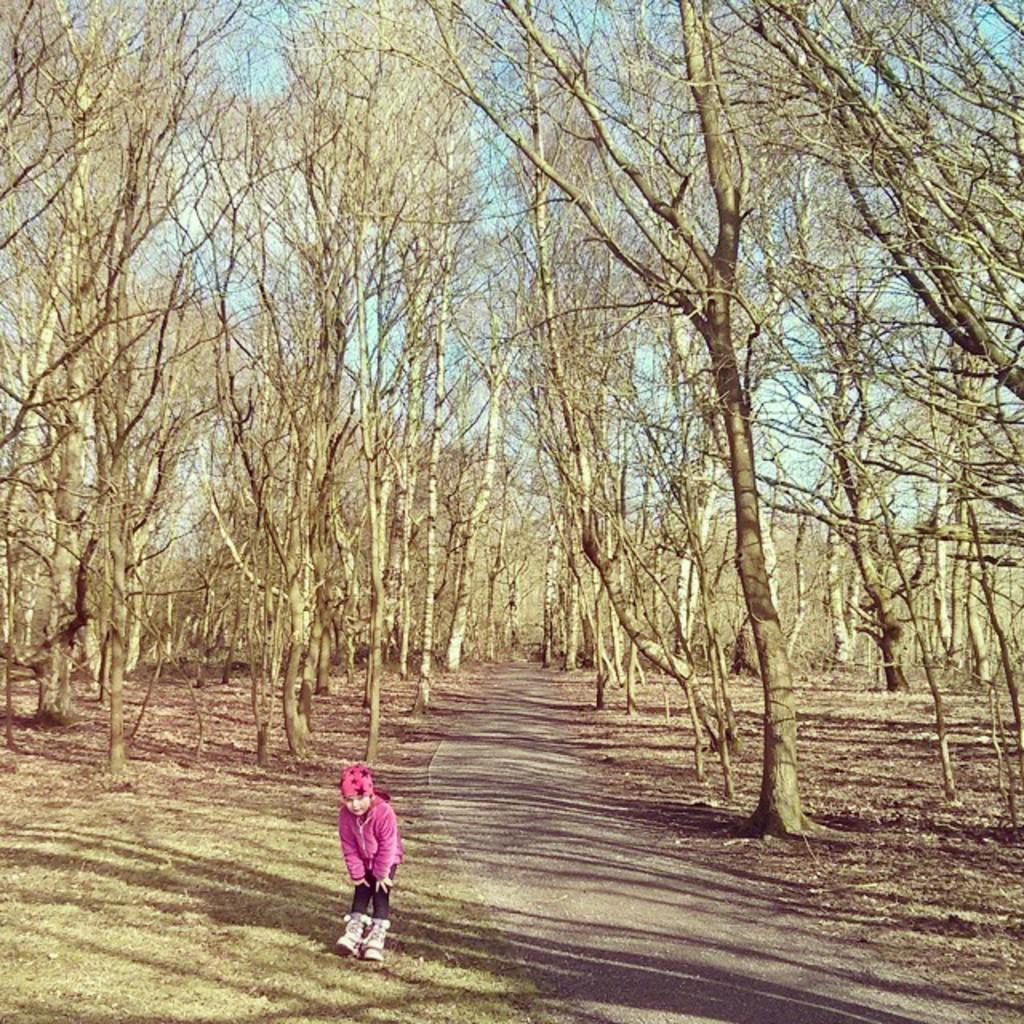How would you summarize this image in a sentence or two? In the picture I can see a child is standing on the ground. In the background I can see trees, the grass, a road and the sky. 